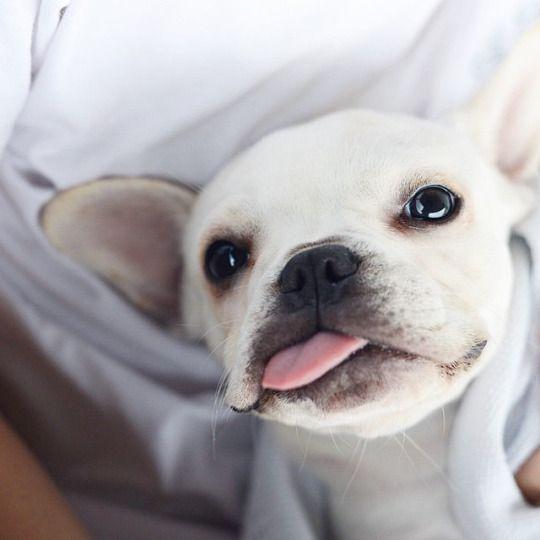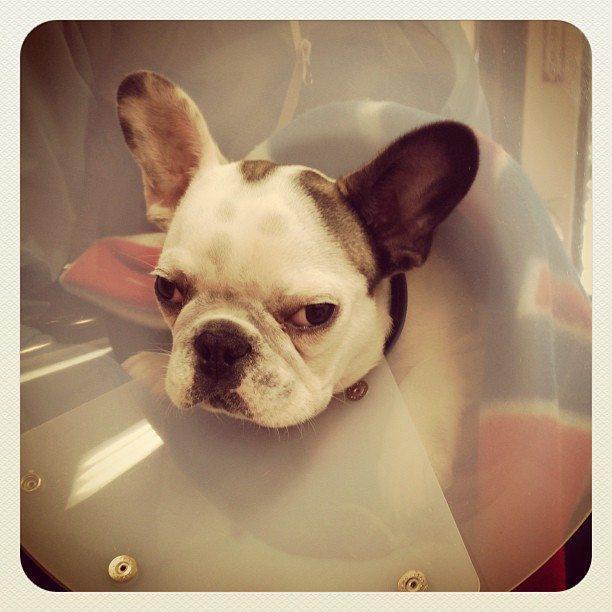The first image is the image on the left, the second image is the image on the right. Evaluate the accuracy of this statement regarding the images: "One of the dogs has its head resting directly on a cushion.". Is it true? Answer yes or no. No. The first image is the image on the left, the second image is the image on the right. Evaluate the accuracy of this statement regarding the images: "There is one dog lying on a wood floor.". Is it true? Answer yes or no. No. 